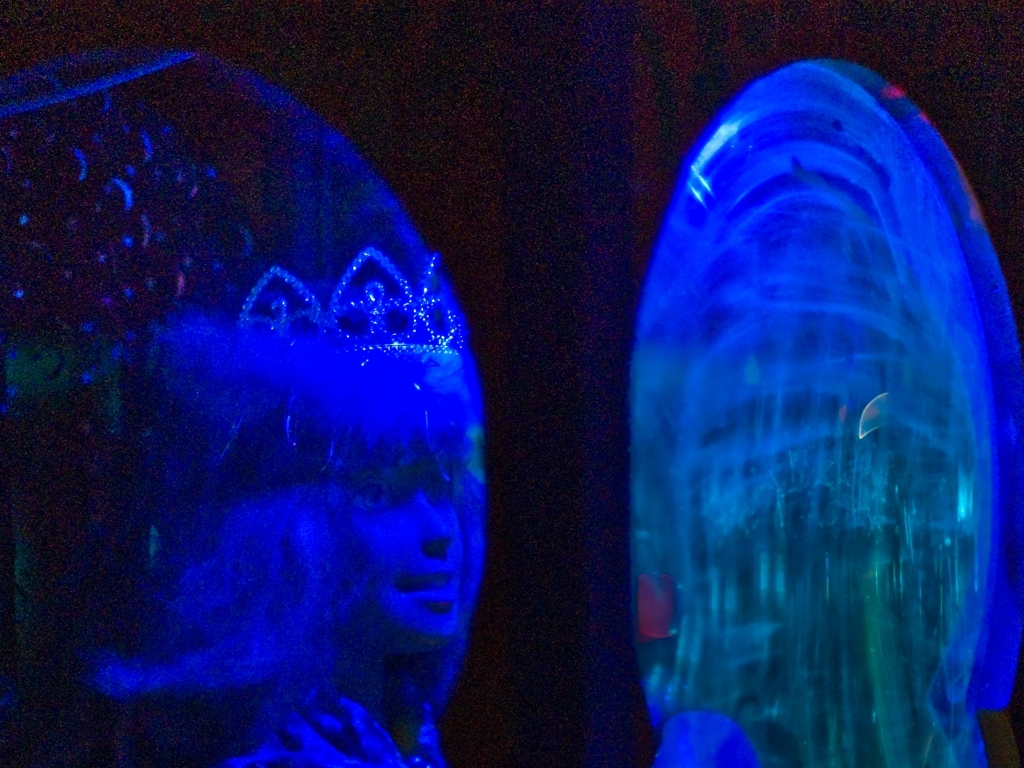Is there any noise in this image? While there certainly is some level of noise perceived in the image, possibly due to low lighting conditions, it's more accurate to describe the noise as moderate rather than extreme. The blue hue and the lighting create a grainy texture that is visible in the darker areas, giving the photograph a somewhat atmospheric quality. 